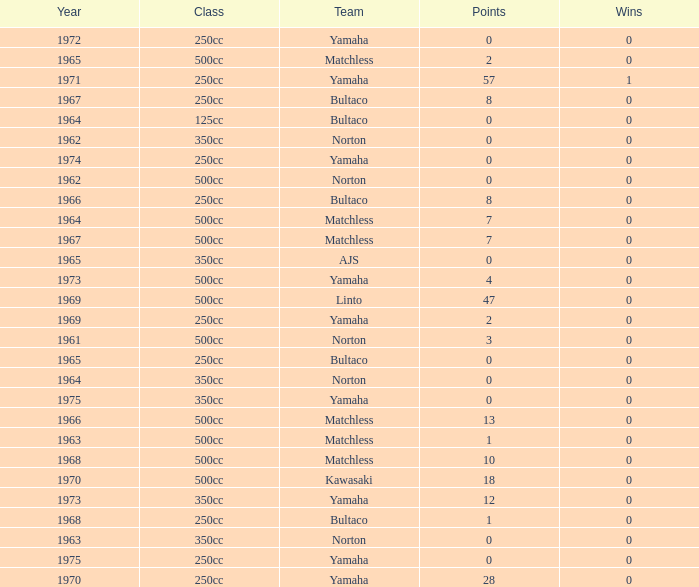What is the sum of all points in 1975 with 0 wins? None. 